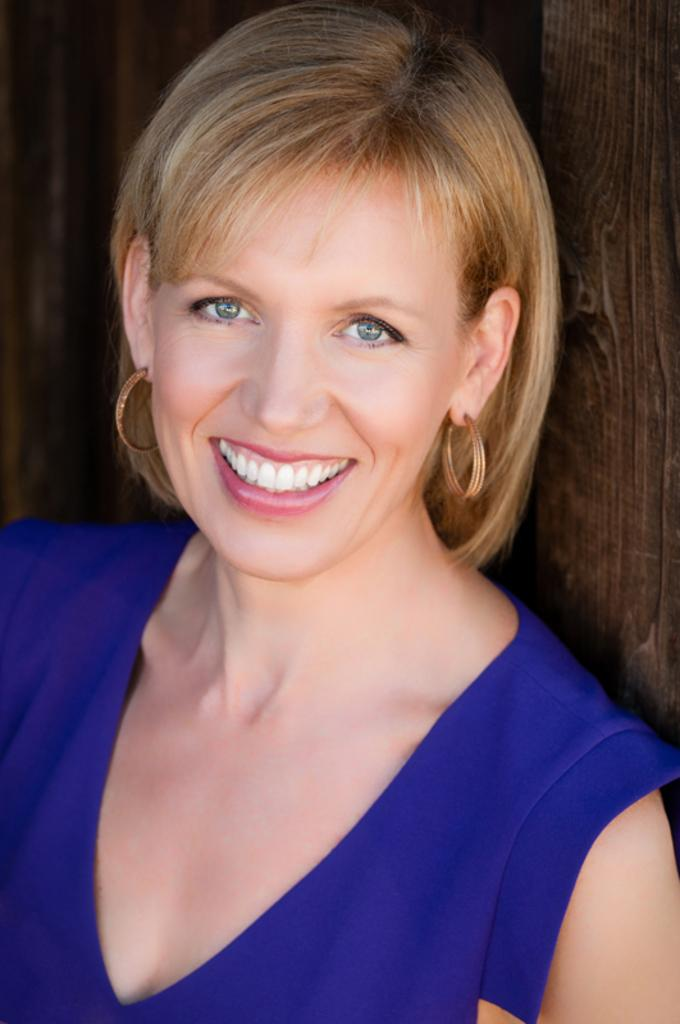What is present in the image? There is a person in the image. Can you describe the person's clothing? The person is wearing a blue dress. What color is the background of the image? The background of the image is brown. What type of duck can be seen in the image? There is no duck present in the image. What time of day is it in the image? The time of day cannot be determined from the image. What type of vegetable is visible in the image? There is no vegetable present in the image. 